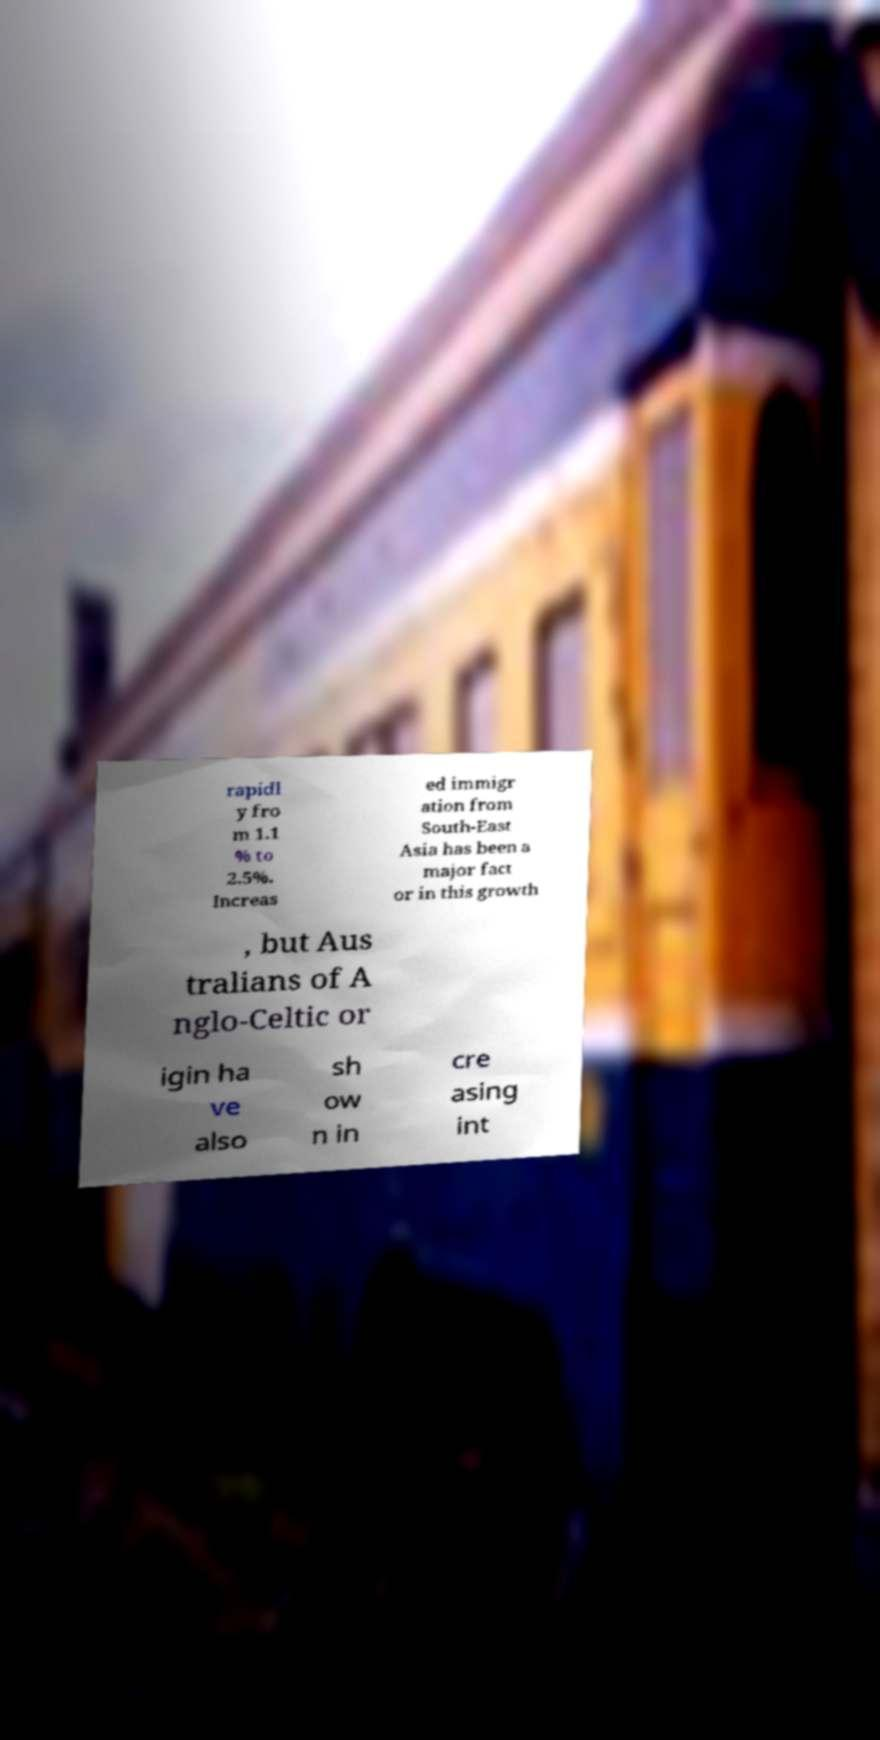Can you read and provide the text displayed in the image?This photo seems to have some interesting text. Can you extract and type it out for me? rapidl y fro m 1.1 % to 2.5%. Increas ed immigr ation from South-East Asia has been a major fact or in this growth , but Aus tralians of A nglo-Celtic or igin ha ve also sh ow n in cre asing int 